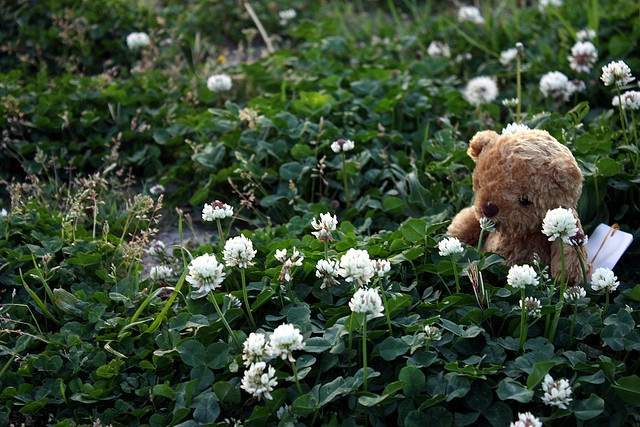Describe the objects in this image and their specific colors. I can see a teddy bear in black, gray, and maroon tones in this image. 